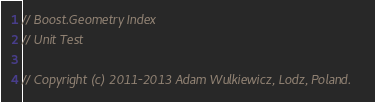Convert code to text. <code><loc_0><loc_0><loc_500><loc_500><_C++_>// Boost.Geometry Index
// Unit Test

// Copyright (c) 2011-2013 Adam Wulkiewicz, Lodz, Poland.
</code> 